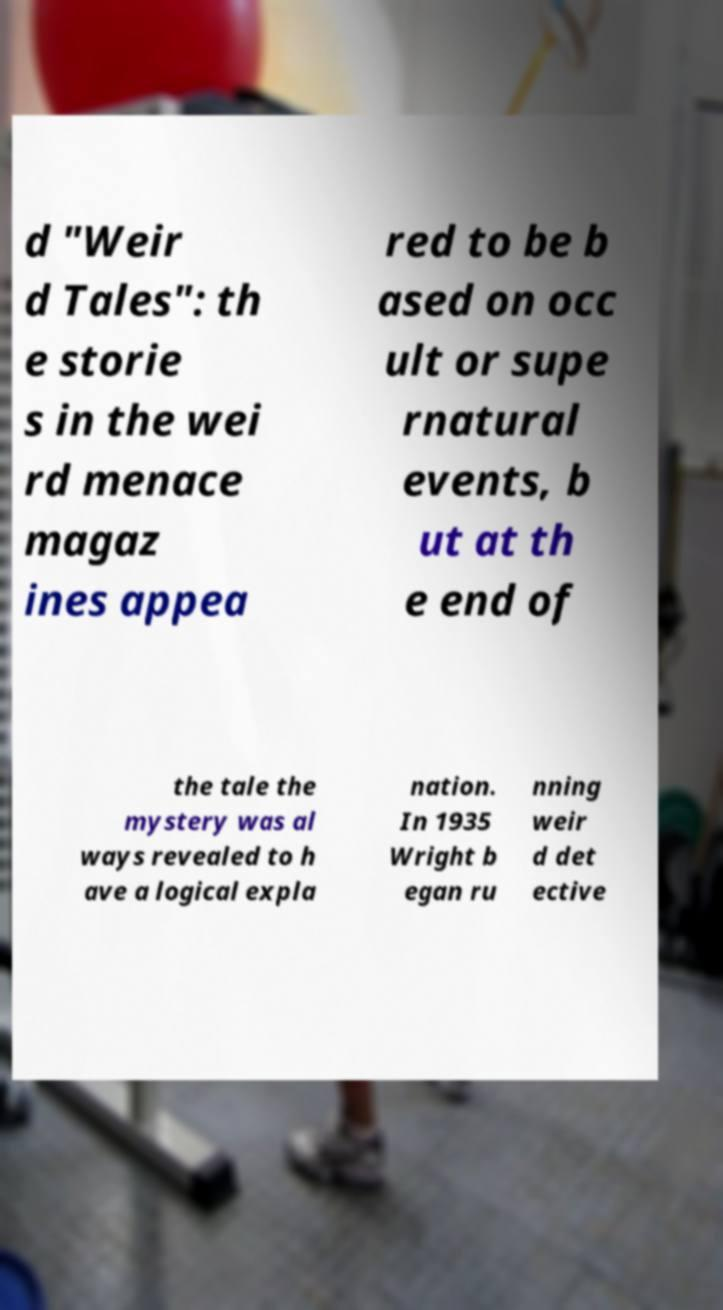Can you read and provide the text displayed in the image?This photo seems to have some interesting text. Can you extract and type it out for me? d "Weir d Tales": th e storie s in the wei rd menace magaz ines appea red to be b ased on occ ult or supe rnatural events, b ut at th e end of the tale the mystery was al ways revealed to h ave a logical expla nation. In 1935 Wright b egan ru nning weir d det ective 